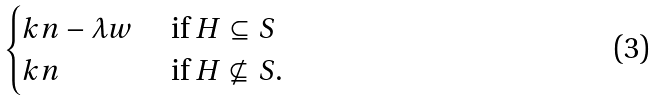<formula> <loc_0><loc_0><loc_500><loc_500>\begin{cases} k n - \lambda w & \text { if $H\subseteq S$} \\ k n & \text { if $H\not\subseteq S$.} \end{cases}</formula> 